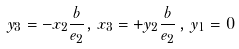Convert formula to latex. <formula><loc_0><loc_0><loc_500><loc_500>y _ { 3 } = - x _ { 2 } \frac { b } { e _ { 2 } } , \, x _ { 3 } = + y _ { 2 } \frac { b } { e _ { 2 } } \, , \, y _ { 1 } = 0</formula> 